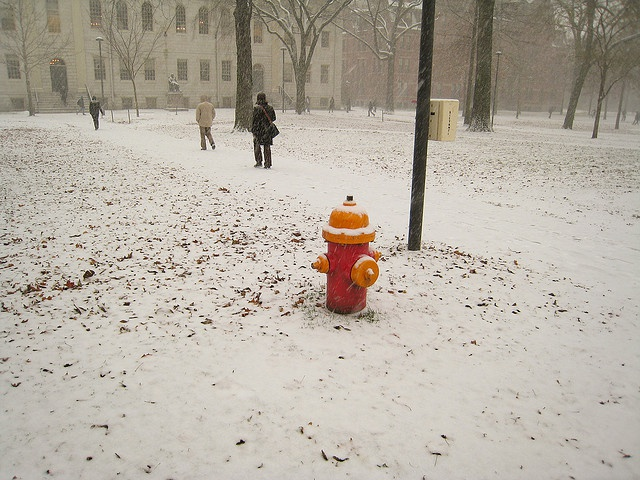Describe the objects in this image and their specific colors. I can see fire hydrant in gray, brown, red, and maroon tones, people in gray and black tones, people in gray and darkgray tones, people in gray, black, and darkgray tones, and handbag in gray, black, ivory, and darkgreen tones in this image. 